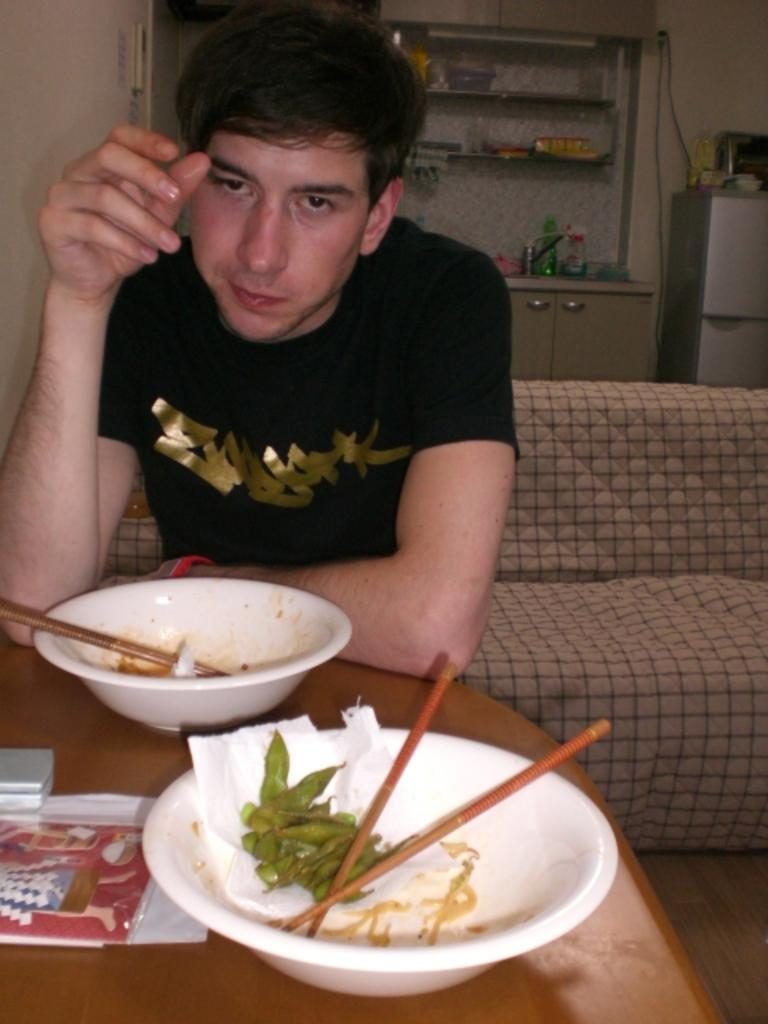What is the man in the image doing? The man is sitting on a sofa in the image. What is located in front of the sofa? There is a table in front of the sofa. What items can be seen on the table? There are bowls, chopsticks, and a paper on the table. What type of cannon is the man using to smash the bowls in the image? There is no cannon present in the image, and the man is not smashing any bowls. 